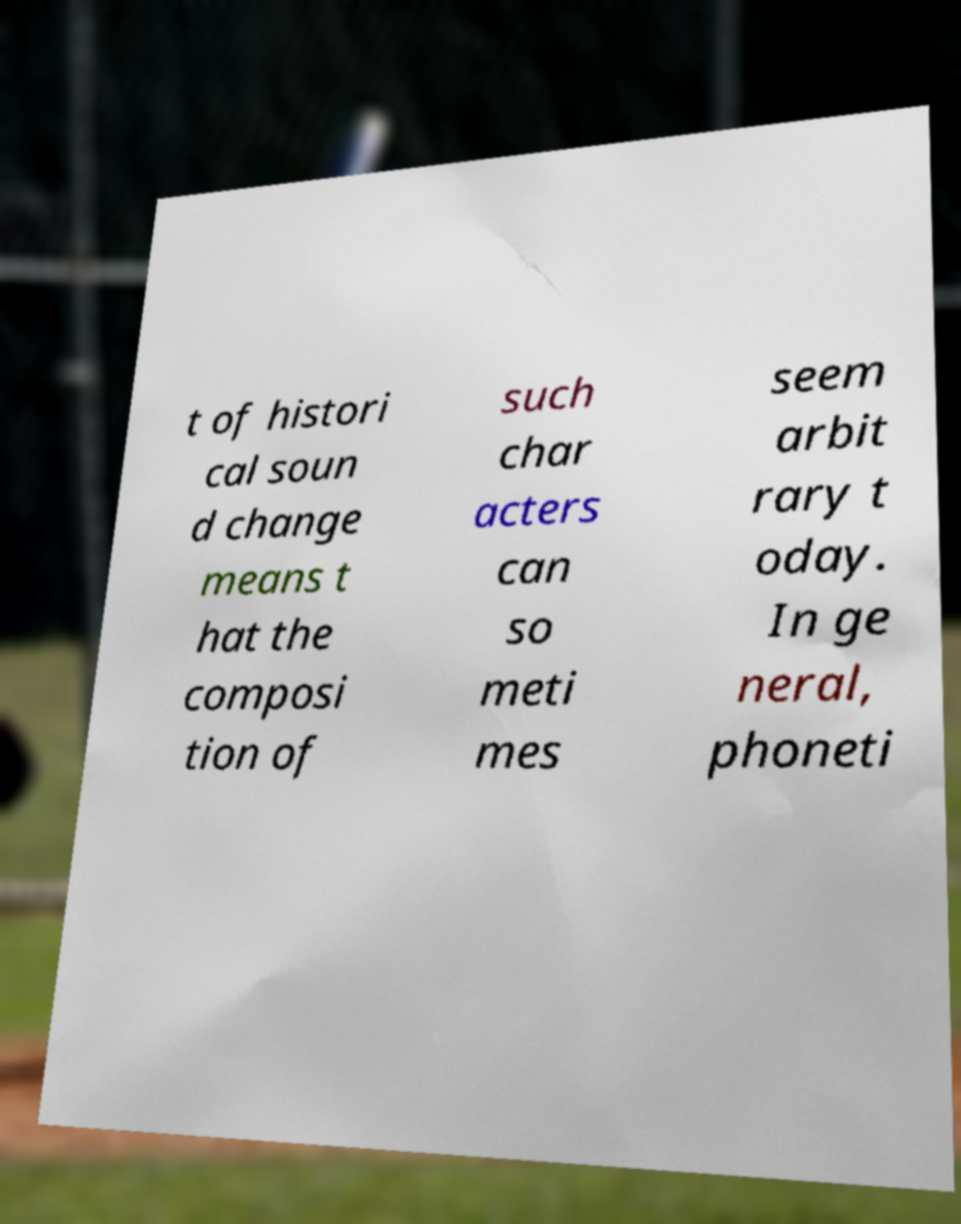Can you read and provide the text displayed in the image?This photo seems to have some interesting text. Can you extract and type it out for me? t of histori cal soun d change means t hat the composi tion of such char acters can so meti mes seem arbit rary t oday. In ge neral, phoneti 